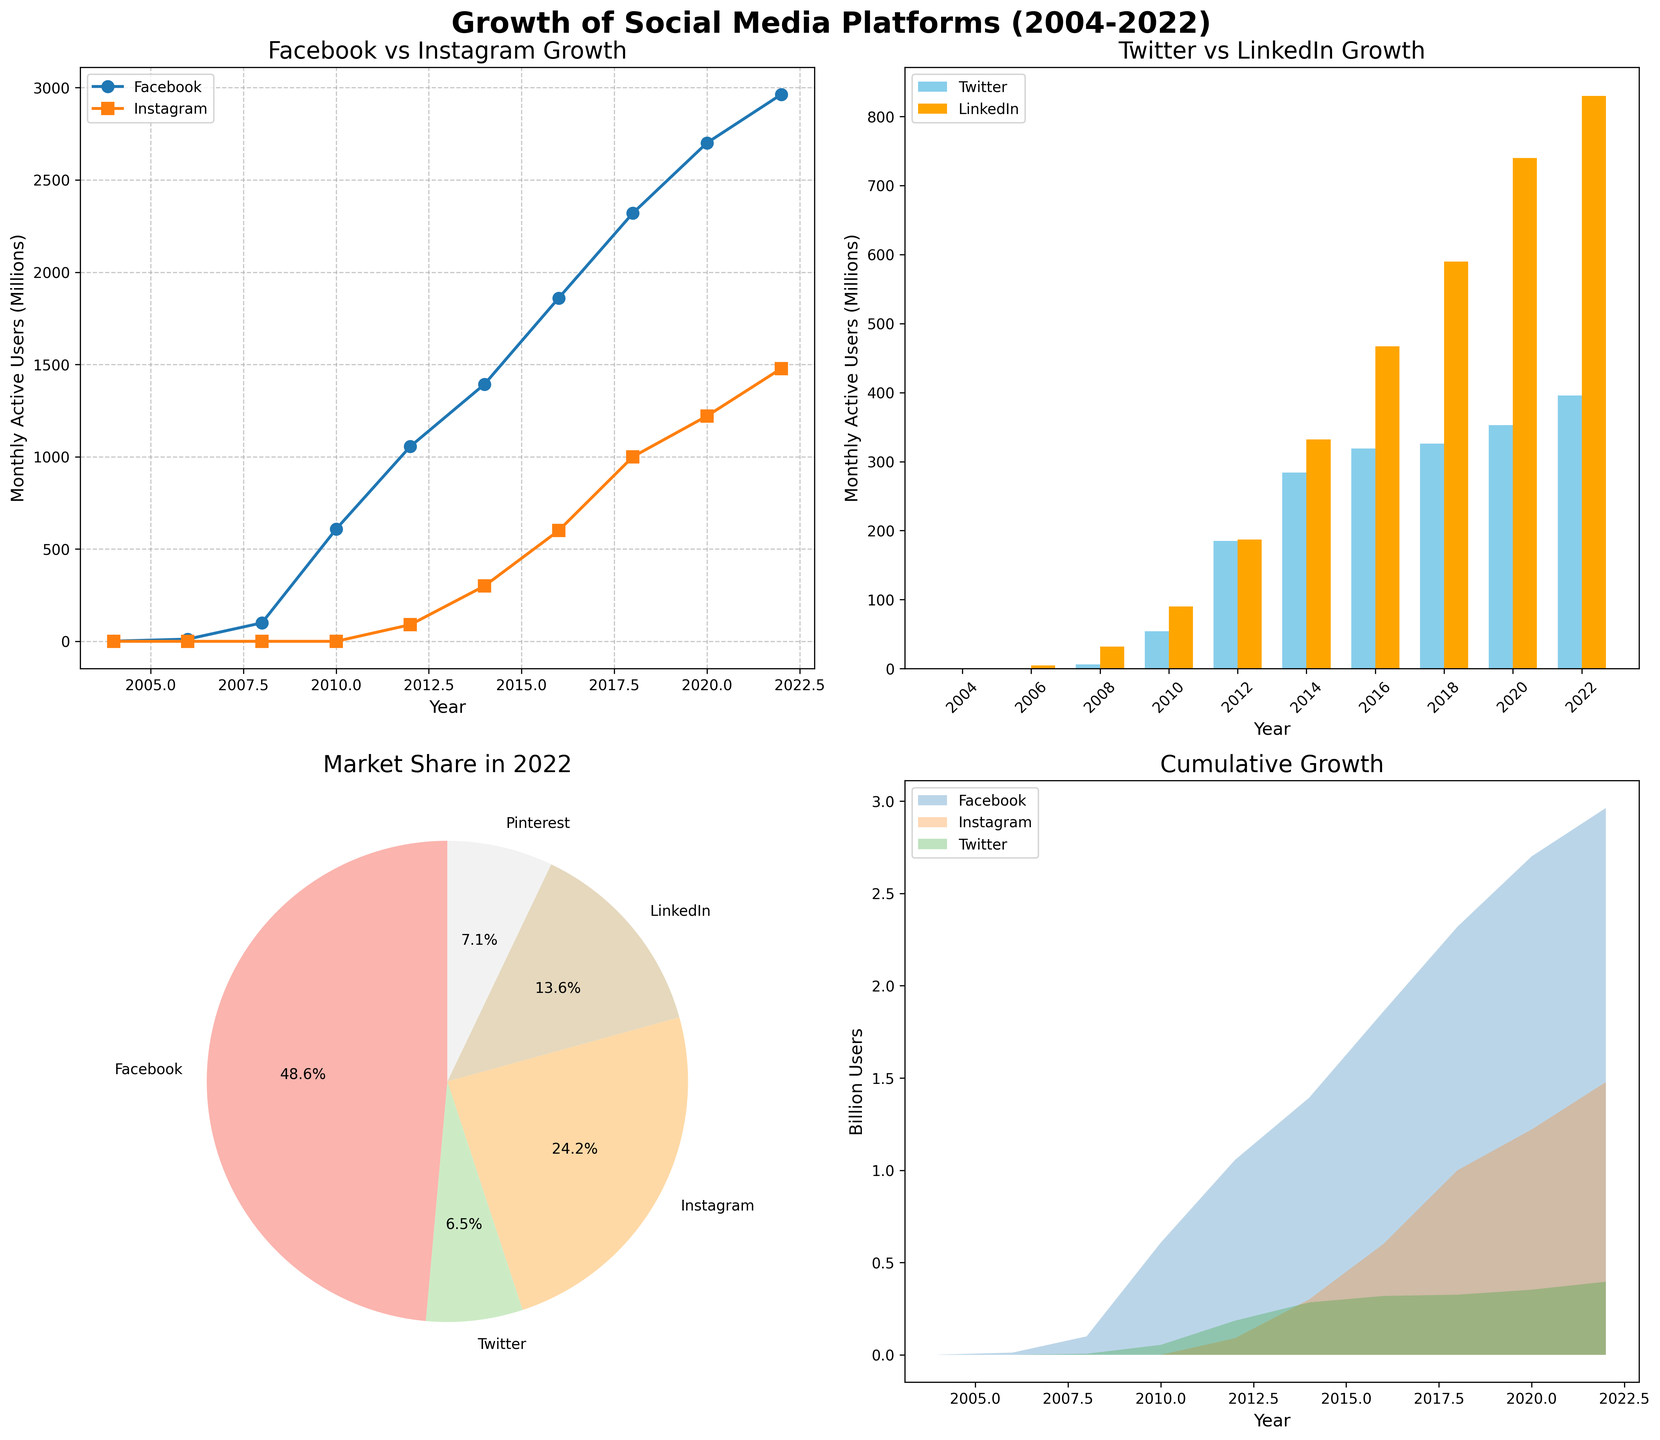How many platforms had 0 monthly active users in 2004? Look at the values for each platform in 2004. Twitter, Instagram, LinkedIn, and Pinterest all have 0 monthly active users in that year.
Answer: 4 Which platform had the highest monthly active users in 2022 as shown in the pie chart? The sizes of each segment in the pie chart represent the monthly active users in 2022. Facebook's segment is the largest.
Answer: Facebook What is the difference in monthly active users between Facebook and Instagram in 2010? In 2010, Facebook had 608 million users, and Instagram had 0. The difference is 608 million.
Answer: 608 million Which two platforms showed the most similar growth trends from 2016 to 2018 according to the line plot? Looking at the line plot for Facebook and Instagram from 2016 to 2018, Facebook grows from 1.86 billion to 2.32 billion, and Instagram grows from 600 million to 1 billion. They both show similar steep growth.
Answer: Facebook and Instagram What percentage of the total market share in 2022 is held by Pinterest, according to the pie chart? The pie chart shows that Pinterest's share is labeled, which is approximately 6.3%. The exact value is visible in the pie section labeled for Pinterest.
Answer: 6.3% Which year did Twitter surpass LinkedIn in monthly active users as shown in the bar plot? Observe the bar heights in the bar plot for Twitter and LinkedIn. In 2012, Twitter's height surpasses LinkedIn for the first time.
Answer: 2012 How many platforms are represented in the cumulative growth area chart? The area chart shows multiple colored areas, each representing a different platform. A total of Facebook, Instagram, and Twitter are included.
Answer: 3 What is the sum of monthly active users for all platforms in 2008? By adding the values for Facebook, Twitter, LinkedIn, Instagram, and Pinterest in 2008: 100M+6M+32M=138M.
Answer: 138 million Comparing 2014 and 2020, which platform experienced the greatest increase in monthly active users according to the bar plot and line plot? For comparison, look at both plots. Facebook climbed from 1393M to 2701M (an increase of 1308M). Instagram climbed from 300M to 1221M, an increase of 921M. Facebook had the largest increase.
Answer: Facebook Cumulatively, which platform reached 1 billion users first according to the area chart? The area chart shows the accumulation trends where Facebook first surpasses the 1-billion-user mark before any other platform.
Answer: Facebook 